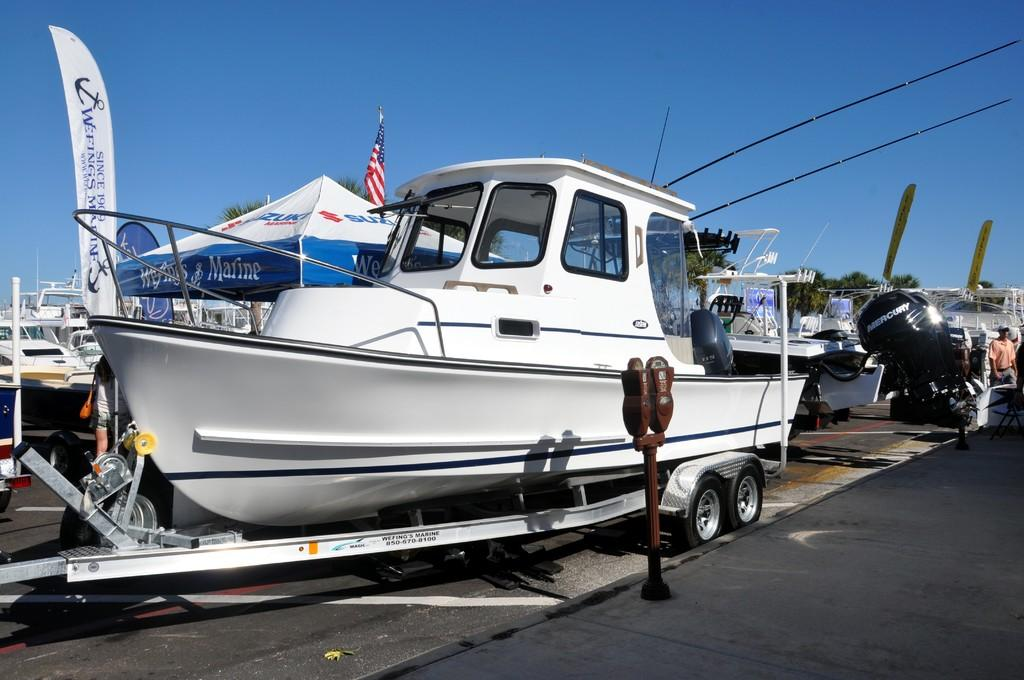What can be seen in the image? There are boats in the image. What is visible in the background of the image? There are trees and a clear sky in the background of the image. What type of jam is being served during the recess in the image? There is no recess or jam present in the image; it features boats and a background with trees and a clear sky. 